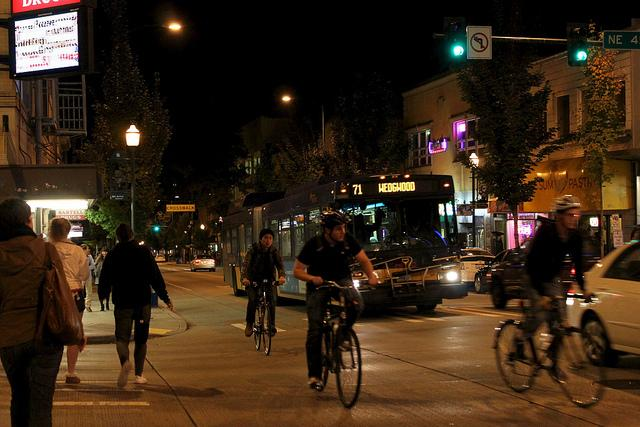What does the sign beside the green light forbid?

Choices:
A) left turns
B) right turns
C) u-turns
D) going straight left turns 